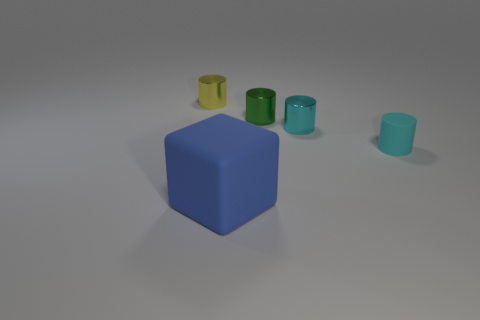Add 2 yellow things. How many objects exist? 7 Subtract all tiny green metal cylinders. How many cylinders are left? 3 Subtract all blue spheres. How many cyan cylinders are left? 2 Subtract 3 cylinders. How many cylinders are left? 1 Subtract all cyan cylinders. How many cylinders are left? 2 Subtract all cylinders. How many objects are left? 1 Subtract all large cubes. Subtract all tiny cyan rubber cylinders. How many objects are left? 3 Add 1 cyan things. How many cyan things are left? 3 Add 3 big yellow matte blocks. How many big yellow matte blocks exist? 3 Subtract 0 blue cylinders. How many objects are left? 5 